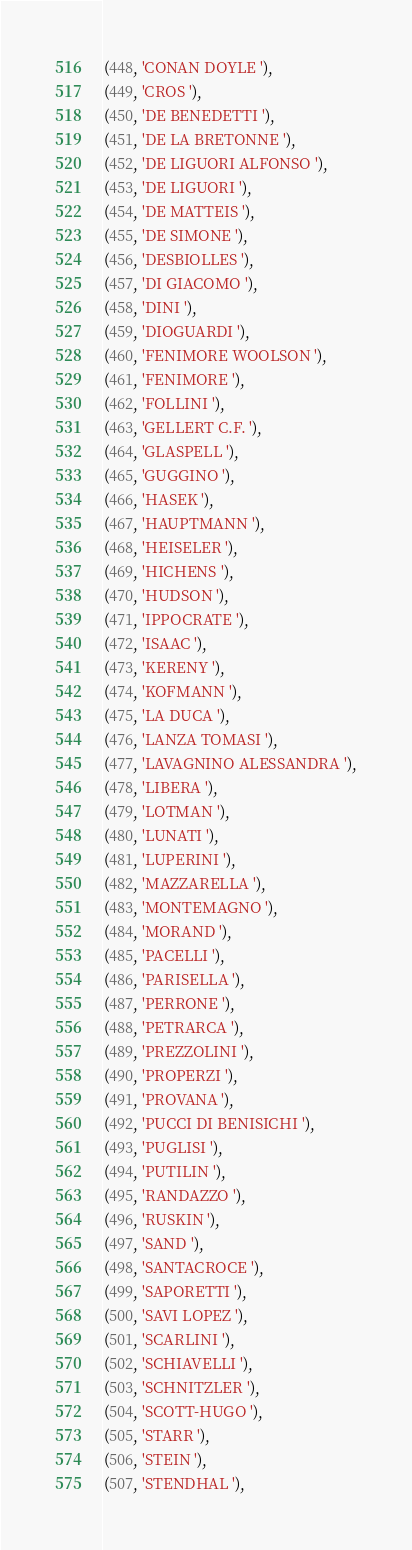<code> <loc_0><loc_0><loc_500><loc_500><_SQL_>(448, 'CONAN DOYLE '),
(449, 'CROS '),
(450, 'DE BENEDETTI '),
(451, 'DE LA BRETONNE '),
(452, 'DE LIGUORI ALFONSO '),
(453, 'DE LIGUORI '),
(454, 'DE MATTEIS '),
(455, 'DE SIMONE '),
(456, 'DESBIOLLES '),
(457, 'DI GIACOMO '),
(458, 'DINI '),
(459, 'DIOGUARDI '),
(460, 'FENIMORE WOOLSON '),
(461, 'FENIMORE '),
(462, 'FOLLINI '),
(463, 'GELLERT C.F. '),
(464, 'GLASPELL '),
(465, 'GUGGINO '),
(466, 'HASEK '),
(467, 'HAUPTMANN '),
(468, 'HEISELER '),
(469, 'HICHENS '),
(470, 'HUDSON '),
(471, 'IPPOCRATE '),
(472, 'ISAAC '),
(473, 'KERENY '),
(474, 'KOFMANN '),
(475, 'LA DUCA '),
(476, 'LANZA TOMASI '),
(477, 'LAVAGNINO ALESSANDRA '),
(478, 'LIBERA '),
(479, 'LOTMAN '),
(480, 'LUNATI '),
(481, 'LUPERINI '),
(482, 'MAZZARELLA '),
(483, 'MONTEMAGNO '),
(484, 'MORAND '),
(485, 'PACELLI '),
(486, 'PARISELLA '),
(487, 'PERRONE '),
(488, 'PETRARCA '),
(489, 'PREZZOLINI '),
(490, 'PROPERZI '),
(491, 'PROVANA '),
(492, 'PUCCI DI BENISICHI '),
(493, 'PUGLISI '),
(494, 'PUTILIN '),
(495, 'RANDAZZO '),
(496, 'RUSKIN '),
(497, 'SAND '),
(498, 'SANTACROCE '),
(499, 'SAPORETTI '),
(500, 'SAVI LOPEZ '),
(501, 'SCARLINI '),
(502, 'SCHIAVELLI '),
(503, 'SCHNITZLER '),
(504, 'SCOTT-HUGO '),
(505, 'STARR '),
(506, 'STEIN '),
(507, 'STENDHAL '),</code> 